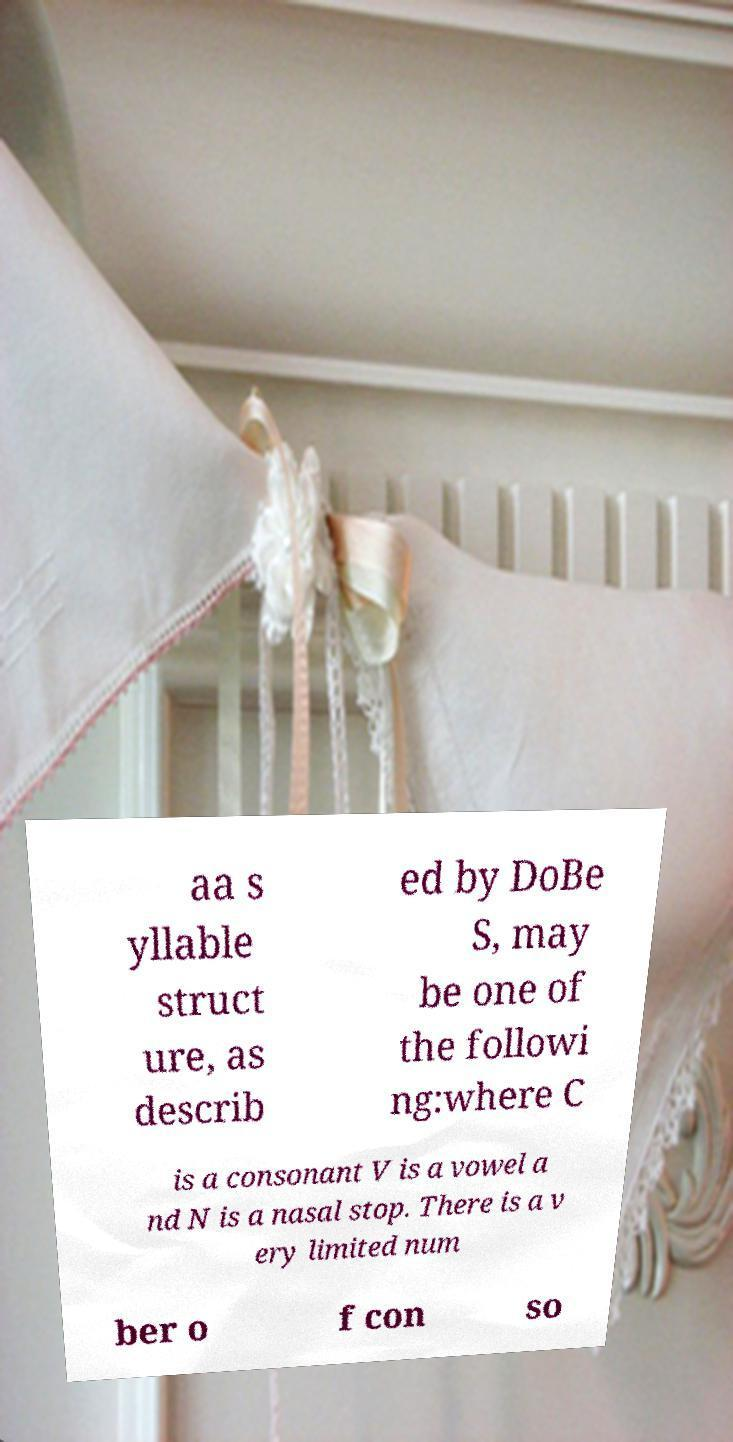Can you accurately transcribe the text from the provided image for me? aa s yllable struct ure, as describ ed by DoBe S, may be one of the followi ng:where C is a consonant V is a vowel a nd N is a nasal stop. There is a v ery limited num ber o f con so 